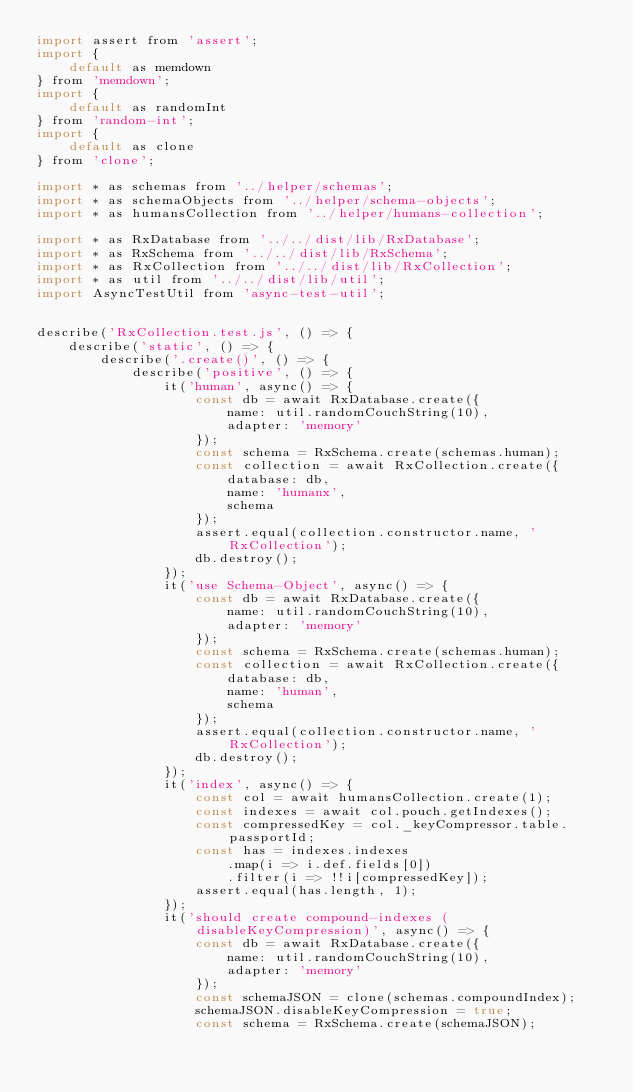<code> <loc_0><loc_0><loc_500><loc_500><_JavaScript_>import assert from 'assert';
import {
    default as memdown
} from 'memdown';
import {
    default as randomInt
} from 'random-int';
import {
    default as clone
} from 'clone';

import * as schemas from '../helper/schemas';
import * as schemaObjects from '../helper/schema-objects';
import * as humansCollection from '../helper/humans-collection';

import * as RxDatabase from '../../dist/lib/RxDatabase';
import * as RxSchema from '../../dist/lib/RxSchema';
import * as RxCollection from '../../dist/lib/RxCollection';
import * as util from '../../dist/lib/util';
import AsyncTestUtil from 'async-test-util';


describe('RxCollection.test.js', () => {
    describe('static', () => {
        describe('.create()', () => {
            describe('positive', () => {
                it('human', async() => {
                    const db = await RxDatabase.create({
                        name: util.randomCouchString(10),
                        adapter: 'memory'
                    });
                    const schema = RxSchema.create(schemas.human);
                    const collection = await RxCollection.create({
                        database: db,
                        name: 'humanx',
                        schema
                    });
                    assert.equal(collection.constructor.name, 'RxCollection');
                    db.destroy();
                });
                it('use Schema-Object', async() => {
                    const db = await RxDatabase.create({
                        name: util.randomCouchString(10),
                        adapter: 'memory'
                    });
                    const schema = RxSchema.create(schemas.human);
                    const collection = await RxCollection.create({
                        database: db,
                        name: 'human',
                        schema
                    });
                    assert.equal(collection.constructor.name, 'RxCollection');
                    db.destroy();
                });
                it('index', async() => {
                    const col = await humansCollection.create(1);
                    const indexes = await col.pouch.getIndexes();
                    const compressedKey = col._keyCompressor.table.passportId;
                    const has = indexes.indexes
                        .map(i => i.def.fields[0])
                        .filter(i => !!i[compressedKey]);
                    assert.equal(has.length, 1);
                });
                it('should create compound-indexes (disableKeyCompression)', async() => {
                    const db = await RxDatabase.create({
                        name: util.randomCouchString(10),
                        adapter: 'memory'
                    });
                    const schemaJSON = clone(schemas.compoundIndex);
                    schemaJSON.disableKeyCompression = true;
                    const schema = RxSchema.create(schemaJSON);</code> 